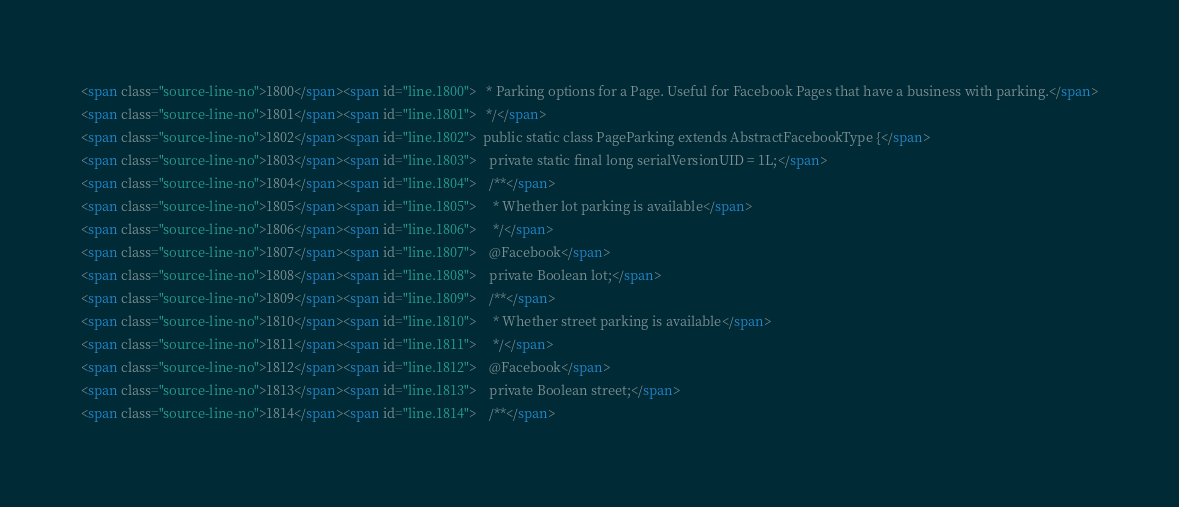<code> <loc_0><loc_0><loc_500><loc_500><_HTML_><span class="source-line-no">1800</span><span id="line.1800">   * Parking options for a Page. Useful for Facebook Pages that have a business with parking.</span>
<span class="source-line-no">1801</span><span id="line.1801">   */</span>
<span class="source-line-no">1802</span><span id="line.1802">  public static class PageParking extends AbstractFacebookType {</span>
<span class="source-line-no">1803</span><span id="line.1803">    private static final long serialVersionUID = 1L;</span>
<span class="source-line-no">1804</span><span id="line.1804">    /**</span>
<span class="source-line-no">1805</span><span id="line.1805">     * Whether lot parking is available</span>
<span class="source-line-no">1806</span><span id="line.1806">     */</span>
<span class="source-line-no">1807</span><span id="line.1807">    @Facebook</span>
<span class="source-line-no">1808</span><span id="line.1808">    private Boolean lot;</span>
<span class="source-line-no">1809</span><span id="line.1809">    /**</span>
<span class="source-line-no">1810</span><span id="line.1810">     * Whether street parking is available</span>
<span class="source-line-no">1811</span><span id="line.1811">     */</span>
<span class="source-line-no">1812</span><span id="line.1812">    @Facebook</span>
<span class="source-line-no">1813</span><span id="line.1813">    private Boolean street;</span>
<span class="source-line-no">1814</span><span id="line.1814">    /**</span></code> 